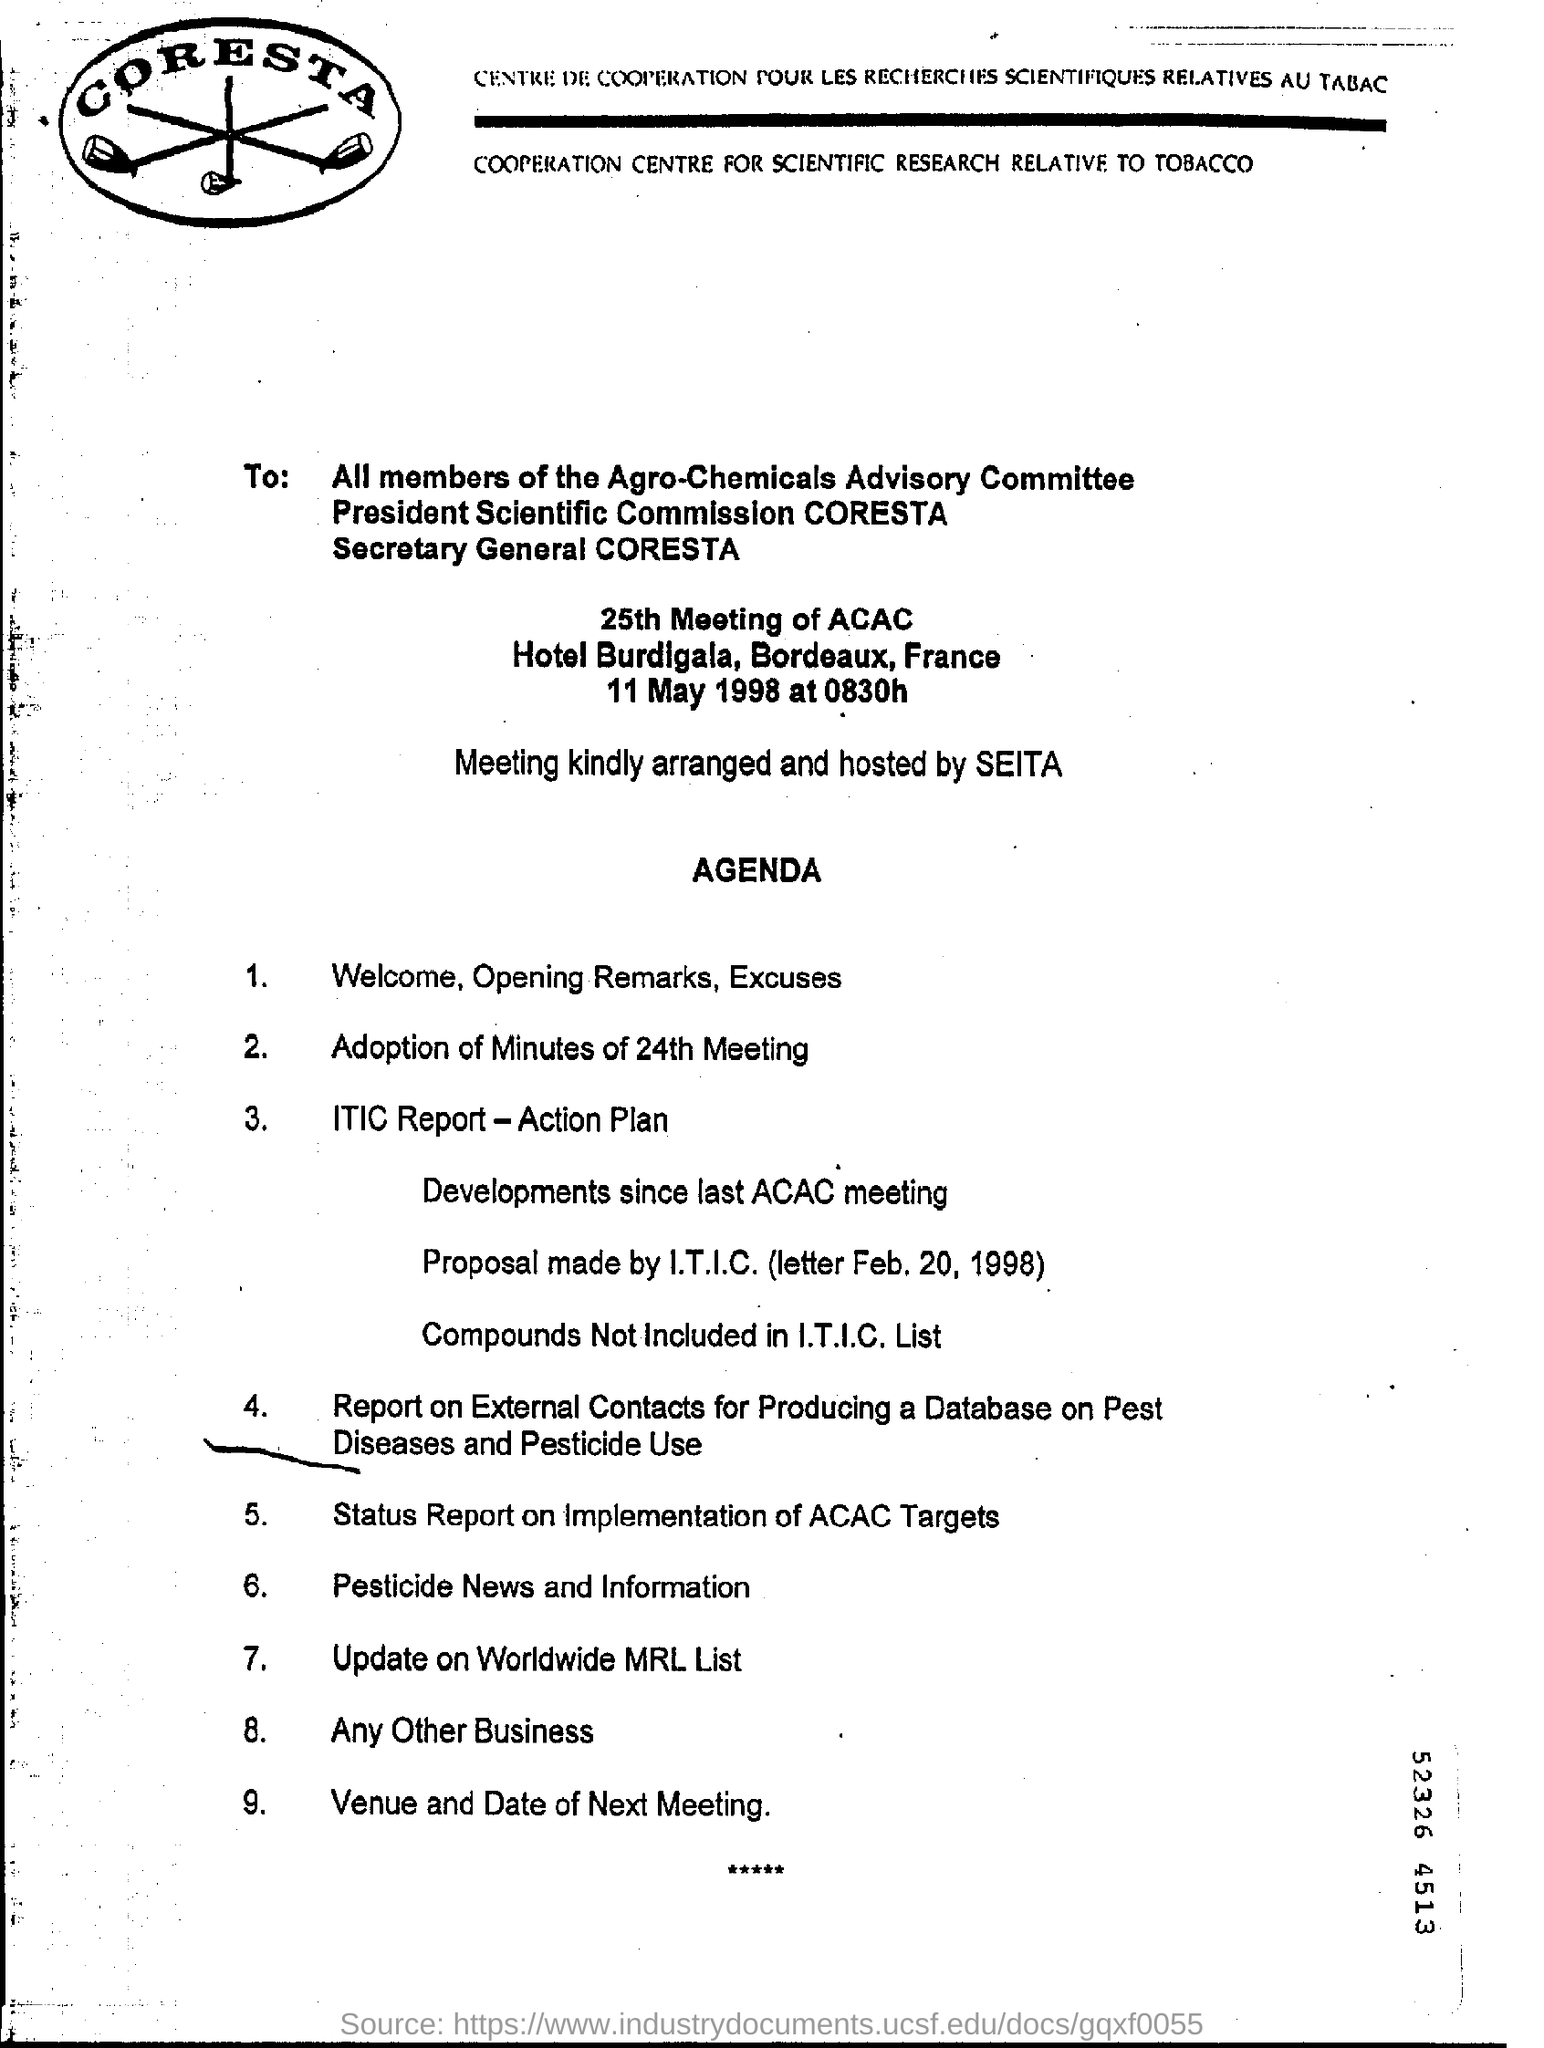Draw attention to some important aspects in this diagram. The meeting is being arranged and hosted by SEITA. 